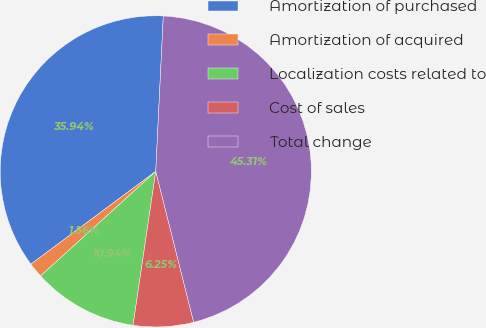Convert chart to OTSL. <chart><loc_0><loc_0><loc_500><loc_500><pie_chart><fcel>Amortization of purchased<fcel>Amortization of acquired<fcel>Localization costs related to<fcel>Cost of sales<fcel>Total change<nl><fcel>35.94%<fcel>1.56%<fcel>10.94%<fcel>6.25%<fcel>45.31%<nl></chart> 